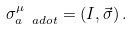Convert formula to latex. <formula><loc_0><loc_0><loc_500><loc_500>\sigma ^ { \mu } _ { a \ a d o t } = ( I , \vec { \sigma } ) \, .</formula> 